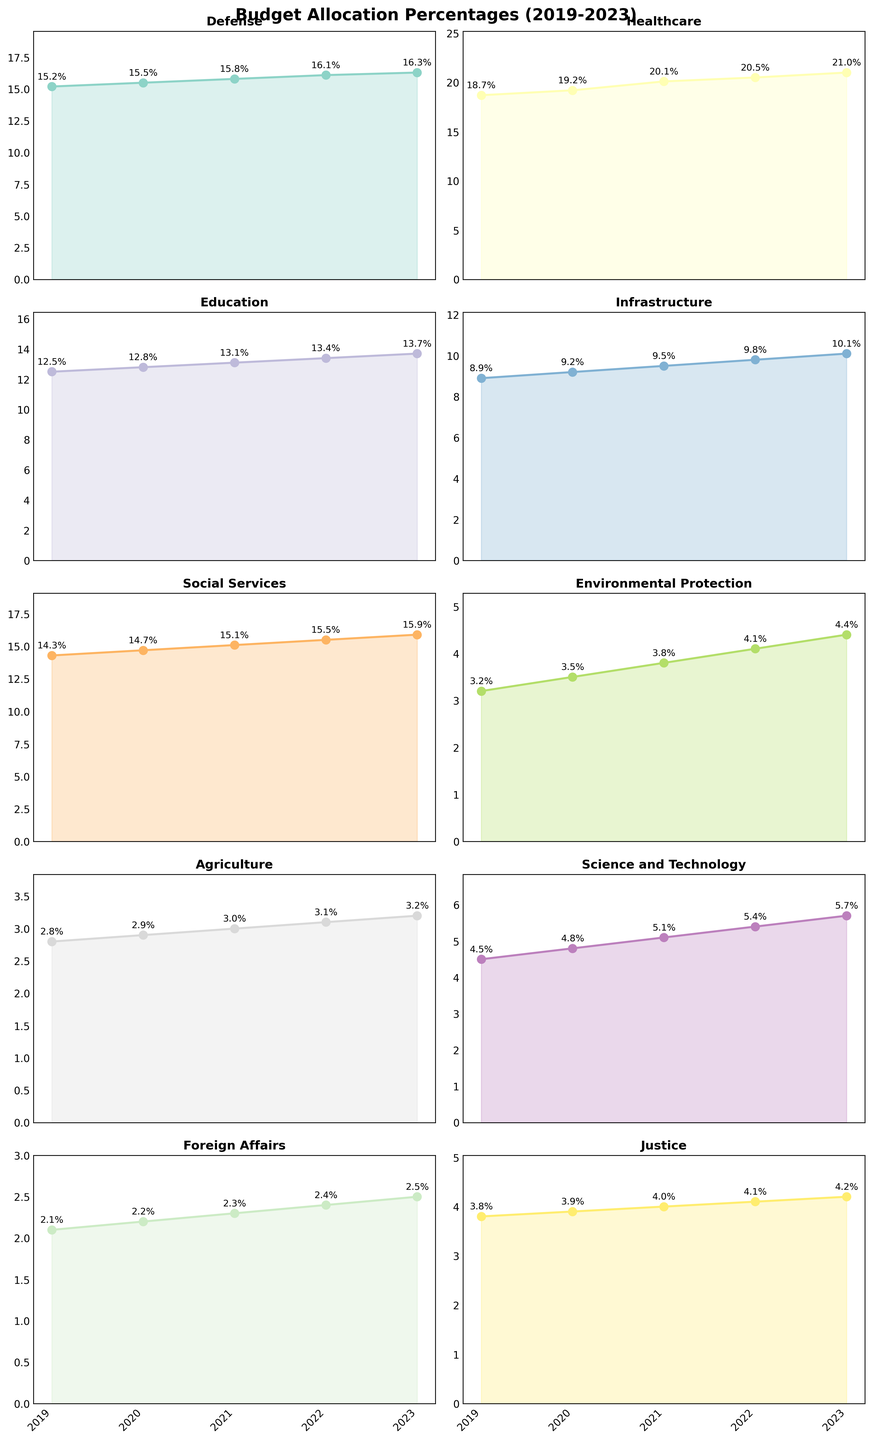What's the overall trend in the budget allocation for Healthcare from 2019 to 2023? The overall trend for Healthcare shows a steady increase from 18.7% in 2019 to 21.0% in 2023. We can see the upward trajectory across the plot.
Answer: Increasing Which department had the highest budget allocation in 2021? In 2021, the Healthcare department had the highest budget allocation at 20.1%, as indicated by the data labels on the plot.
Answer: Healthcare Compare the budget allocations of Defense and Education in 2023. Which one is higher and by how much? In 2023, the Defense budget allocation is 16.3%, and the Education budget allocation is 13.7%. The difference is calculated as 16.3% - 13.7% = 2.6%. Thus, Defense has a 2.6% higher allocation.
Answer: Defense by 2.6% What is the average budget allocation percentage for Science and Technology over the 5 years? To find the average, sum the budget allocations for Science and Technology over the years 2019 to 2023: 4.5 + 4.8 + 5.1 + 5.4 + 5.7 = 25.5. Then, divide by 5: 25.5 / 5 = 5.1%.
Answer: 5.1% Which department shows the most significant increase in budget allocation percent from 2019 to 2023? Calculate the difference for each department: 
- Defense: 16.3 - 15.2 = 1.1
- Healthcare: 21.0 - 18.7 = 2.3
- Education: 13.7 - 12.5 = 1.2
- Infrastructure: 10.1 - 8.9 = 1.2
- Social Services: 15.9 - 14.3 = 1.6
- Environmental Protection: 4.4 - 3.2 = 1.2
- Agriculture: 3.2 - 2.8 = 0.4
- Science and Technology: 5.7 - 4.5 = 1.2
- Foreign Affairs: 2.5 - 2.1 = 0.4
- Justice: 4.2 - 3.8 = 0.4
Healthcare shows the highest increase of 2.3%.
Answer: Healthcare By examining the plot, which department's budget allocation remained relatively flat compared to others? Departments like Agriculture and Justice show relatively smaller increases over the years (only 0.4% each), which indicates a flatter line on the plot compared to others.
Answer: Agriculture and Justice Which years did the Environmental Protection department see a visible or notable increase in budget allocation? From the start: 
- 2019 to 2020: 0.3% increase (3.2% to 3.5%)
- 2020 to 2021: 0.3% increase (3.5% to 3.8%)
- 2021 to 2022: 0.3% increase (3.8% to 4.1%)
- 2022 to 2023: 0.3% increase (4.1% to 4.4%)
Although each year sees a consistent increase of 0.3%, each increment is visible on the plot.
Answer: Annually from 2019 to 2023 What is the total budget allocation percentage for the departments of Defense, Healthcare, and Education in 2023? Sum of the budget allocations in 2023: 
- Defense: 16.3%
- Healthcare: 21.0%
- Education: 13.7%
Total: 16.3 + 21.0 + 13.7 = 51.0%.
Answer: 51.0% Which department had the least budget allocation in 2022, and what was the percentage? In 2022, the Foreign Affairs department had the least budget allocation at 2.4%, as indicated by the data labels on the plot.
Answer: Foreign Affairs, 2.4% 